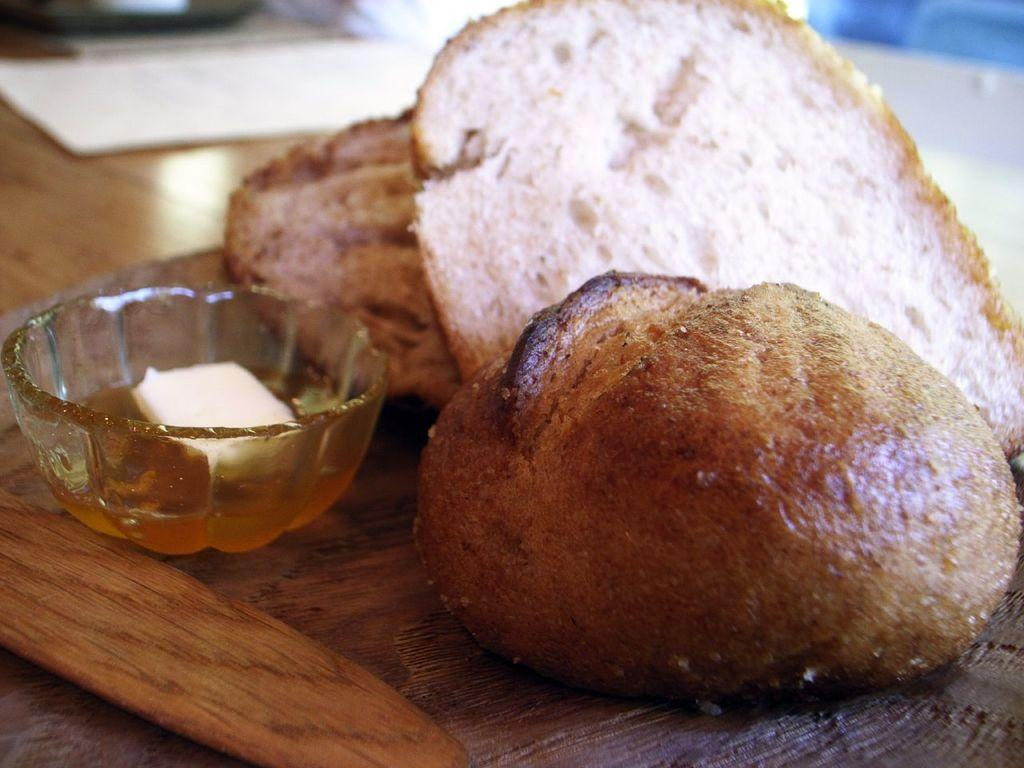What is the main subject of the image? The main subject of the image is food in the center. Can you describe the arrangement of the bowls in the image? There is a bowl inside another bowl in the image. What is inside the inner bowl? The inner bowl contains butter. How would you describe the background of the image? The background of the image is blurry. What type of thread is being used to hold the weight in the image? There is no thread or weight present in the image. Can you see a toad in the image? There is no toad present in the image. 